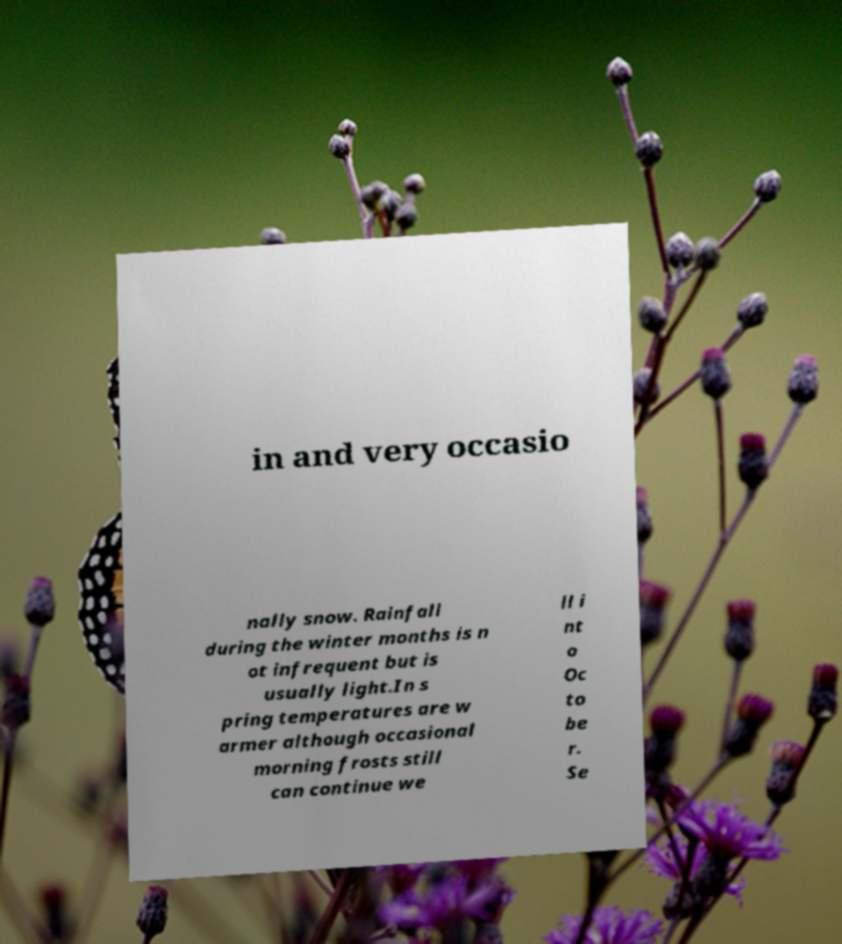There's text embedded in this image that I need extracted. Can you transcribe it verbatim? in and very occasio nally snow. Rainfall during the winter months is n ot infrequent but is usually light.In s pring temperatures are w armer although occasional morning frosts still can continue we ll i nt o Oc to be r. Se 